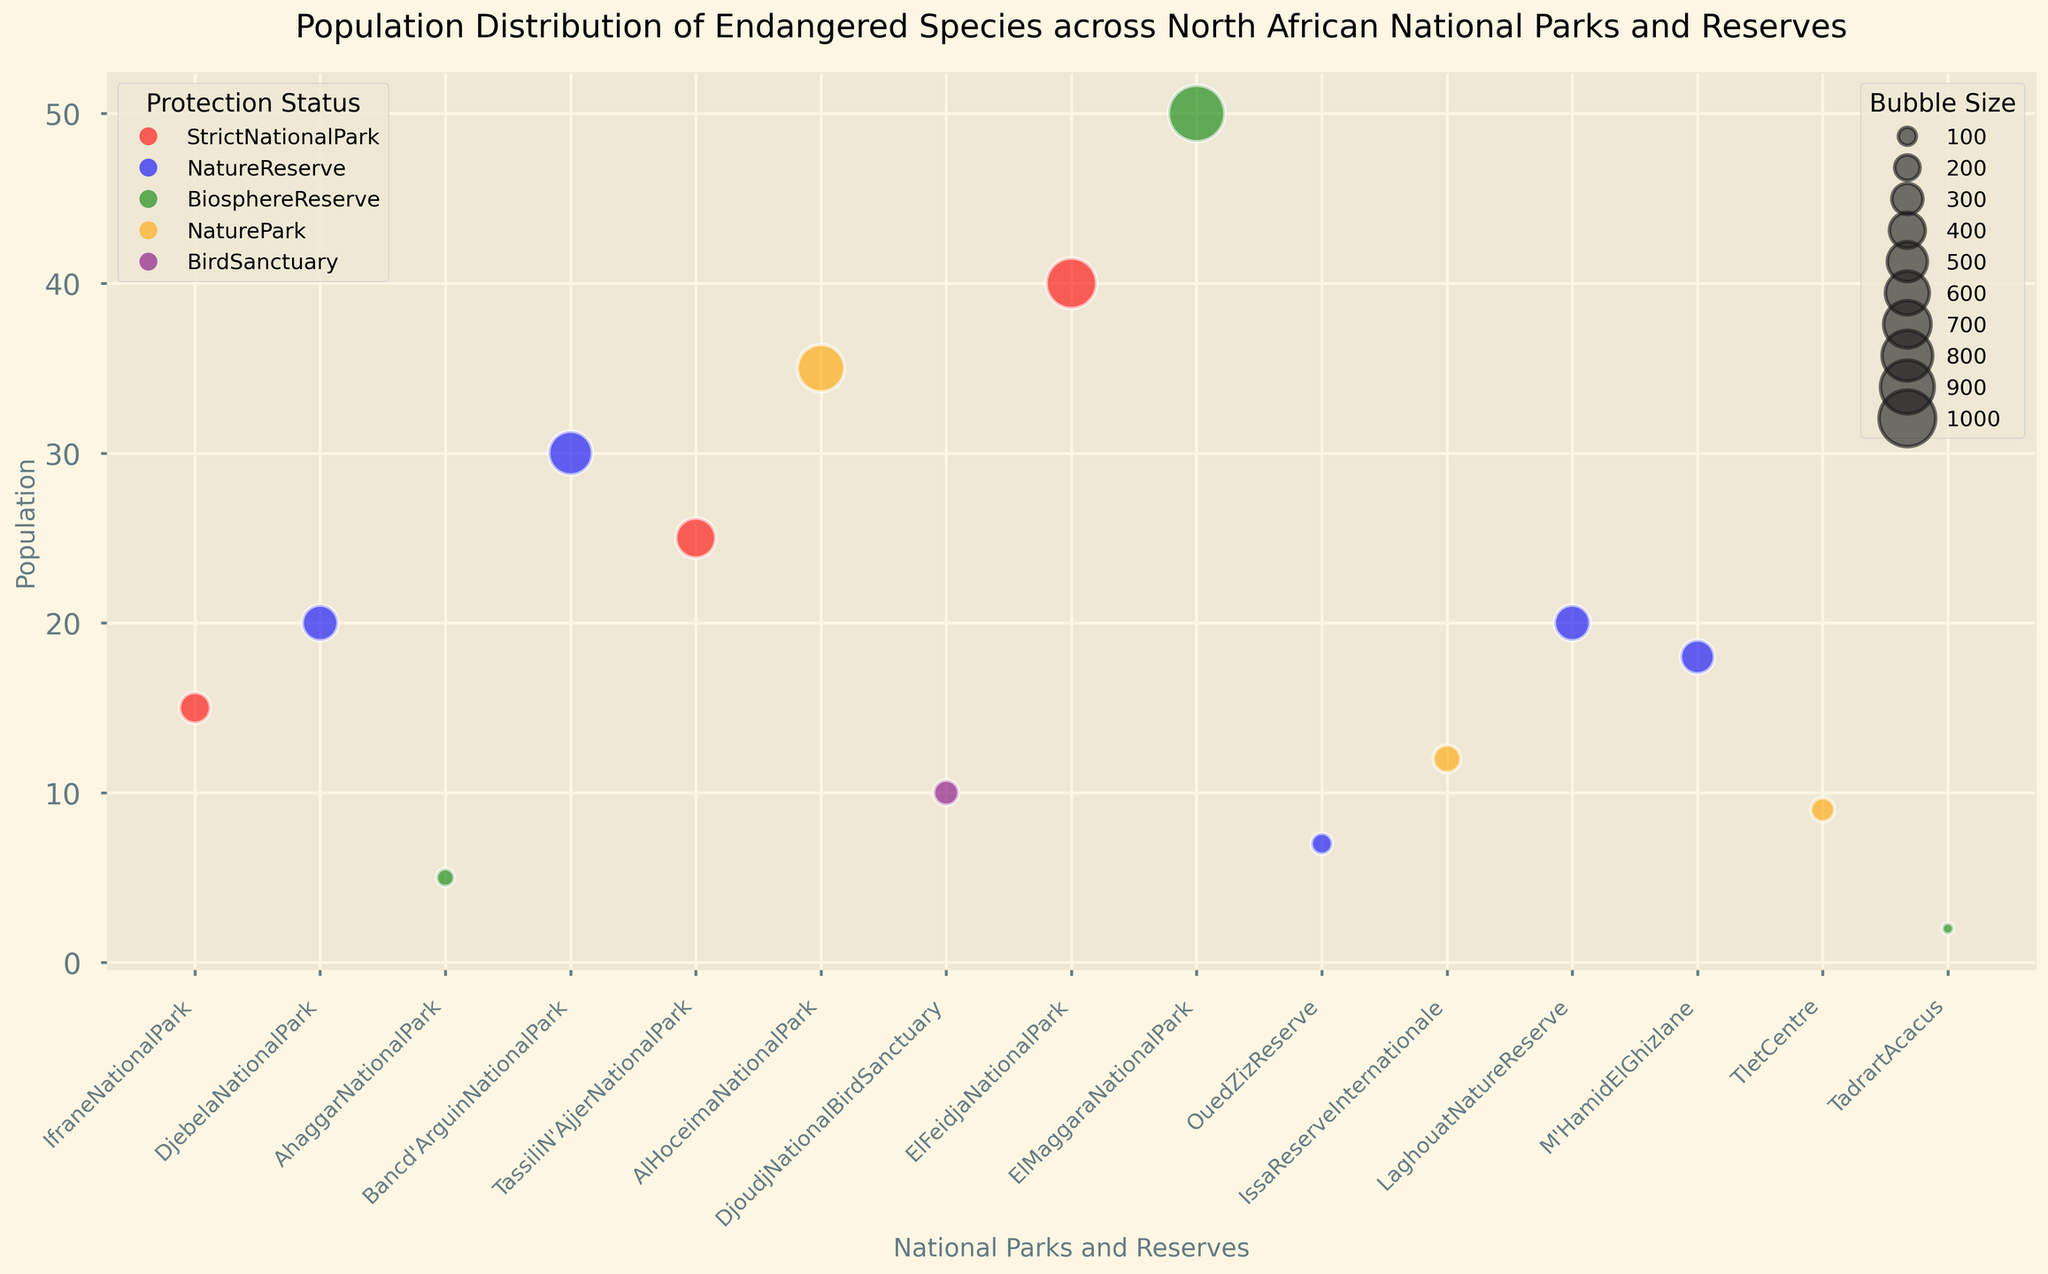Which species has the largest population? The largest bubble on the chart suggests the largest population. The Mediterranean Monk Seal has the largest bubble size of 35.
Answer: Mediterranean Monk Seal Compare the population of the Barbary Lion and the Barbary Sheep, which one is larger? Locate the bubbles for Barbary Lion and Barbary Sheep. Barbary Lion has a population of 15 and Barbary Sheep has a population of 25. 25 is greater than 15.
Answer: Barbary Sheep Which protection status covers the highest number of species? Check the legend for the different protection statuses and count the number of species indicated by the color coding. Nature Reserve has the most species.
Answer: Nature Reserve What is the total population of all species in Biosphere Reserves? Add the populations of all species categorized under Biosphere Reserves. Saharan Cheetah (5), Egyptian Tortoise (50), and African Leopard (2) sum up to 5 + 50 + 2.
Answer: 57 Which national park or reserve has the lowest population of an endangered species, and what species is it? Find the smallest bubble size on the chart. The African Leopard in Tadrart Acacus is the smallest bubble with a population of 2.
Answer: Tadrart Acacus, African Leopard How many species have populations between 10 and 20? Count the bubbles with sizes indicating populations between 10 and 20. The species are Barbary Lion (15), Cuvier's Gazelle (20), African Wild Dog (12), Golden Jackal (20), and Fennec Fox (18), which amounts to five species.
Answer: 5 What is the average population of species in Strict National Parks? The species in Strict National Parks are Barbary Lion (15), Barbary Sheep (25), and Barbary Red Deer (40). The average is (15 + 25 + 40) / 3. Calculate the sum first which is 80, then divide by 3.
Answer: 26.67 Which species in Nature Reserves has the highest population? Examine the bubbles colored for Nature Reserves and compare their sizes. The largest population in a Nature Reserve is the Addax Antelope with a population of 30.
Answer: Addax Antelope Are there more species in Bird Sanctuaries or Nature Parks? Bird Sanctuary has one species (Dama Gazelle) and Nature Parks have three species (Mediterranean Monk Seal, African Wild Dog, North African Elephant). Compare the counts.
Answer: Nature Parks 